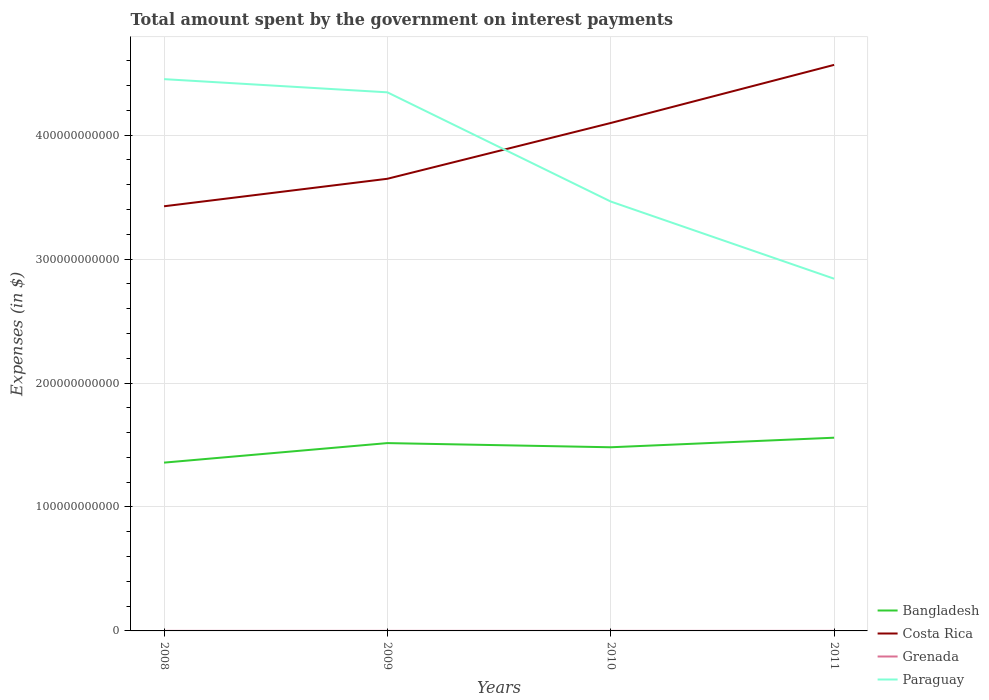Does the line corresponding to Paraguay intersect with the line corresponding to Costa Rica?
Offer a terse response. Yes. Across all years, what is the maximum amount spent on interest payments by the government in Bangladesh?
Provide a short and direct response. 1.36e+11. What is the total amount spent on interest payments by the government in Costa Rica in the graph?
Provide a short and direct response. -9.19e+1. What is the difference between the highest and the second highest amount spent on interest payments by the government in Costa Rica?
Your answer should be compact. 1.14e+11. What is the difference between the highest and the lowest amount spent on interest payments by the government in Paraguay?
Make the answer very short. 2. Is the amount spent on interest payments by the government in Costa Rica strictly greater than the amount spent on interest payments by the government in Grenada over the years?
Provide a succinct answer. No. How many years are there in the graph?
Offer a terse response. 4. What is the difference between two consecutive major ticks on the Y-axis?
Keep it short and to the point. 1.00e+11. Are the values on the major ticks of Y-axis written in scientific E-notation?
Your response must be concise. No. Does the graph contain grids?
Make the answer very short. Yes. Where does the legend appear in the graph?
Make the answer very short. Bottom right. How many legend labels are there?
Make the answer very short. 4. What is the title of the graph?
Your answer should be very brief. Total amount spent by the government on interest payments. Does "Niger" appear as one of the legend labels in the graph?
Offer a terse response. No. What is the label or title of the Y-axis?
Ensure brevity in your answer.  Expenses (in $). What is the Expenses (in $) in Bangladesh in 2008?
Make the answer very short. 1.36e+11. What is the Expenses (in $) of Costa Rica in 2008?
Offer a terse response. 3.43e+11. What is the Expenses (in $) in Grenada in 2008?
Make the answer very short. 3.49e+07. What is the Expenses (in $) of Paraguay in 2008?
Your answer should be compact. 4.45e+11. What is the Expenses (in $) in Bangladesh in 2009?
Give a very brief answer. 1.52e+11. What is the Expenses (in $) in Costa Rica in 2009?
Your answer should be compact. 3.65e+11. What is the Expenses (in $) of Grenada in 2009?
Provide a short and direct response. 4.53e+07. What is the Expenses (in $) in Paraguay in 2009?
Your response must be concise. 4.35e+11. What is the Expenses (in $) in Bangladesh in 2010?
Keep it short and to the point. 1.48e+11. What is the Expenses (in $) of Costa Rica in 2010?
Give a very brief answer. 4.10e+11. What is the Expenses (in $) of Grenada in 2010?
Keep it short and to the point. 4.30e+07. What is the Expenses (in $) of Paraguay in 2010?
Your answer should be very brief. 3.46e+11. What is the Expenses (in $) in Bangladesh in 2011?
Provide a short and direct response. 1.56e+11. What is the Expenses (in $) of Costa Rica in 2011?
Your response must be concise. 4.57e+11. What is the Expenses (in $) of Grenada in 2011?
Make the answer very short. 5.16e+07. What is the Expenses (in $) of Paraguay in 2011?
Provide a succinct answer. 2.84e+11. Across all years, what is the maximum Expenses (in $) in Bangladesh?
Provide a short and direct response. 1.56e+11. Across all years, what is the maximum Expenses (in $) in Costa Rica?
Your answer should be very brief. 4.57e+11. Across all years, what is the maximum Expenses (in $) in Grenada?
Offer a very short reply. 5.16e+07. Across all years, what is the maximum Expenses (in $) of Paraguay?
Offer a terse response. 4.45e+11. Across all years, what is the minimum Expenses (in $) of Bangladesh?
Give a very brief answer. 1.36e+11. Across all years, what is the minimum Expenses (in $) in Costa Rica?
Offer a very short reply. 3.43e+11. Across all years, what is the minimum Expenses (in $) of Grenada?
Provide a short and direct response. 3.49e+07. Across all years, what is the minimum Expenses (in $) of Paraguay?
Offer a terse response. 2.84e+11. What is the total Expenses (in $) of Bangladesh in the graph?
Your answer should be compact. 5.91e+11. What is the total Expenses (in $) in Costa Rica in the graph?
Provide a short and direct response. 1.57e+12. What is the total Expenses (in $) of Grenada in the graph?
Provide a short and direct response. 1.75e+08. What is the total Expenses (in $) of Paraguay in the graph?
Provide a short and direct response. 1.51e+12. What is the difference between the Expenses (in $) of Bangladesh in 2008 and that in 2009?
Provide a short and direct response. -1.58e+1. What is the difference between the Expenses (in $) in Costa Rica in 2008 and that in 2009?
Keep it short and to the point. -2.22e+1. What is the difference between the Expenses (in $) of Grenada in 2008 and that in 2009?
Offer a very short reply. -1.04e+07. What is the difference between the Expenses (in $) of Paraguay in 2008 and that in 2009?
Give a very brief answer. 1.06e+1. What is the difference between the Expenses (in $) in Bangladesh in 2008 and that in 2010?
Your answer should be very brief. -1.24e+1. What is the difference between the Expenses (in $) of Costa Rica in 2008 and that in 2010?
Make the answer very short. -6.72e+1. What is the difference between the Expenses (in $) of Grenada in 2008 and that in 2010?
Your answer should be compact. -8.10e+06. What is the difference between the Expenses (in $) of Paraguay in 2008 and that in 2010?
Your response must be concise. 9.87e+1. What is the difference between the Expenses (in $) in Bangladesh in 2008 and that in 2011?
Your answer should be very brief. -2.01e+1. What is the difference between the Expenses (in $) of Costa Rica in 2008 and that in 2011?
Offer a very short reply. -1.14e+11. What is the difference between the Expenses (in $) of Grenada in 2008 and that in 2011?
Ensure brevity in your answer.  -1.67e+07. What is the difference between the Expenses (in $) in Paraguay in 2008 and that in 2011?
Give a very brief answer. 1.61e+11. What is the difference between the Expenses (in $) in Bangladesh in 2009 and that in 2010?
Provide a short and direct response. 3.37e+09. What is the difference between the Expenses (in $) of Costa Rica in 2009 and that in 2010?
Provide a succinct answer. -4.50e+1. What is the difference between the Expenses (in $) of Grenada in 2009 and that in 2010?
Provide a succinct answer. 2.30e+06. What is the difference between the Expenses (in $) of Paraguay in 2009 and that in 2010?
Offer a terse response. 8.81e+1. What is the difference between the Expenses (in $) of Bangladesh in 2009 and that in 2011?
Give a very brief answer. -4.35e+09. What is the difference between the Expenses (in $) of Costa Rica in 2009 and that in 2011?
Ensure brevity in your answer.  -9.19e+1. What is the difference between the Expenses (in $) of Grenada in 2009 and that in 2011?
Your answer should be very brief. -6.30e+06. What is the difference between the Expenses (in $) in Paraguay in 2009 and that in 2011?
Keep it short and to the point. 1.50e+11. What is the difference between the Expenses (in $) in Bangladesh in 2010 and that in 2011?
Your answer should be compact. -7.72e+09. What is the difference between the Expenses (in $) of Costa Rica in 2010 and that in 2011?
Your answer should be very brief. -4.69e+1. What is the difference between the Expenses (in $) in Grenada in 2010 and that in 2011?
Offer a very short reply. -8.60e+06. What is the difference between the Expenses (in $) of Paraguay in 2010 and that in 2011?
Ensure brevity in your answer.  6.23e+1. What is the difference between the Expenses (in $) of Bangladesh in 2008 and the Expenses (in $) of Costa Rica in 2009?
Make the answer very short. -2.29e+11. What is the difference between the Expenses (in $) of Bangladesh in 2008 and the Expenses (in $) of Grenada in 2009?
Your answer should be compact. 1.36e+11. What is the difference between the Expenses (in $) in Bangladesh in 2008 and the Expenses (in $) in Paraguay in 2009?
Keep it short and to the point. -2.99e+11. What is the difference between the Expenses (in $) of Costa Rica in 2008 and the Expenses (in $) of Grenada in 2009?
Ensure brevity in your answer.  3.43e+11. What is the difference between the Expenses (in $) in Costa Rica in 2008 and the Expenses (in $) in Paraguay in 2009?
Offer a terse response. -9.19e+1. What is the difference between the Expenses (in $) in Grenada in 2008 and the Expenses (in $) in Paraguay in 2009?
Your answer should be very brief. -4.34e+11. What is the difference between the Expenses (in $) in Bangladesh in 2008 and the Expenses (in $) in Costa Rica in 2010?
Give a very brief answer. -2.74e+11. What is the difference between the Expenses (in $) in Bangladesh in 2008 and the Expenses (in $) in Grenada in 2010?
Ensure brevity in your answer.  1.36e+11. What is the difference between the Expenses (in $) of Bangladesh in 2008 and the Expenses (in $) of Paraguay in 2010?
Your response must be concise. -2.11e+11. What is the difference between the Expenses (in $) in Costa Rica in 2008 and the Expenses (in $) in Grenada in 2010?
Offer a very short reply. 3.43e+11. What is the difference between the Expenses (in $) of Costa Rica in 2008 and the Expenses (in $) of Paraguay in 2010?
Make the answer very short. -3.82e+09. What is the difference between the Expenses (in $) of Grenada in 2008 and the Expenses (in $) of Paraguay in 2010?
Provide a succinct answer. -3.46e+11. What is the difference between the Expenses (in $) in Bangladesh in 2008 and the Expenses (in $) in Costa Rica in 2011?
Provide a short and direct response. -3.21e+11. What is the difference between the Expenses (in $) in Bangladesh in 2008 and the Expenses (in $) in Grenada in 2011?
Provide a short and direct response. 1.36e+11. What is the difference between the Expenses (in $) in Bangladesh in 2008 and the Expenses (in $) in Paraguay in 2011?
Keep it short and to the point. -1.48e+11. What is the difference between the Expenses (in $) of Costa Rica in 2008 and the Expenses (in $) of Grenada in 2011?
Give a very brief answer. 3.43e+11. What is the difference between the Expenses (in $) of Costa Rica in 2008 and the Expenses (in $) of Paraguay in 2011?
Keep it short and to the point. 5.84e+1. What is the difference between the Expenses (in $) of Grenada in 2008 and the Expenses (in $) of Paraguay in 2011?
Your response must be concise. -2.84e+11. What is the difference between the Expenses (in $) in Bangladesh in 2009 and the Expenses (in $) in Costa Rica in 2010?
Provide a succinct answer. -2.58e+11. What is the difference between the Expenses (in $) of Bangladesh in 2009 and the Expenses (in $) of Grenada in 2010?
Keep it short and to the point. 1.51e+11. What is the difference between the Expenses (in $) of Bangladesh in 2009 and the Expenses (in $) of Paraguay in 2010?
Provide a short and direct response. -1.95e+11. What is the difference between the Expenses (in $) in Costa Rica in 2009 and the Expenses (in $) in Grenada in 2010?
Give a very brief answer. 3.65e+11. What is the difference between the Expenses (in $) of Costa Rica in 2009 and the Expenses (in $) of Paraguay in 2010?
Offer a very short reply. 1.84e+1. What is the difference between the Expenses (in $) of Grenada in 2009 and the Expenses (in $) of Paraguay in 2010?
Your answer should be compact. -3.46e+11. What is the difference between the Expenses (in $) in Bangladesh in 2009 and the Expenses (in $) in Costa Rica in 2011?
Provide a succinct answer. -3.05e+11. What is the difference between the Expenses (in $) in Bangladesh in 2009 and the Expenses (in $) in Grenada in 2011?
Make the answer very short. 1.51e+11. What is the difference between the Expenses (in $) in Bangladesh in 2009 and the Expenses (in $) in Paraguay in 2011?
Your answer should be compact. -1.33e+11. What is the difference between the Expenses (in $) of Costa Rica in 2009 and the Expenses (in $) of Grenada in 2011?
Provide a short and direct response. 3.65e+11. What is the difference between the Expenses (in $) in Costa Rica in 2009 and the Expenses (in $) in Paraguay in 2011?
Offer a very short reply. 8.06e+1. What is the difference between the Expenses (in $) of Grenada in 2009 and the Expenses (in $) of Paraguay in 2011?
Your response must be concise. -2.84e+11. What is the difference between the Expenses (in $) of Bangladesh in 2010 and the Expenses (in $) of Costa Rica in 2011?
Give a very brief answer. -3.08e+11. What is the difference between the Expenses (in $) of Bangladesh in 2010 and the Expenses (in $) of Grenada in 2011?
Your answer should be very brief. 1.48e+11. What is the difference between the Expenses (in $) in Bangladesh in 2010 and the Expenses (in $) in Paraguay in 2011?
Your answer should be compact. -1.36e+11. What is the difference between the Expenses (in $) in Costa Rica in 2010 and the Expenses (in $) in Grenada in 2011?
Make the answer very short. 4.10e+11. What is the difference between the Expenses (in $) in Costa Rica in 2010 and the Expenses (in $) in Paraguay in 2011?
Your response must be concise. 1.26e+11. What is the difference between the Expenses (in $) of Grenada in 2010 and the Expenses (in $) of Paraguay in 2011?
Make the answer very short. -2.84e+11. What is the average Expenses (in $) of Bangladesh per year?
Provide a succinct answer. 1.48e+11. What is the average Expenses (in $) of Costa Rica per year?
Keep it short and to the point. 3.93e+11. What is the average Expenses (in $) in Grenada per year?
Make the answer very short. 4.37e+07. What is the average Expenses (in $) in Paraguay per year?
Make the answer very short. 3.78e+11. In the year 2008, what is the difference between the Expenses (in $) of Bangladesh and Expenses (in $) of Costa Rica?
Keep it short and to the point. -2.07e+11. In the year 2008, what is the difference between the Expenses (in $) of Bangladesh and Expenses (in $) of Grenada?
Your answer should be very brief. 1.36e+11. In the year 2008, what is the difference between the Expenses (in $) in Bangladesh and Expenses (in $) in Paraguay?
Provide a succinct answer. -3.09e+11. In the year 2008, what is the difference between the Expenses (in $) of Costa Rica and Expenses (in $) of Grenada?
Your answer should be very brief. 3.43e+11. In the year 2008, what is the difference between the Expenses (in $) in Costa Rica and Expenses (in $) in Paraguay?
Provide a succinct answer. -1.03e+11. In the year 2008, what is the difference between the Expenses (in $) of Grenada and Expenses (in $) of Paraguay?
Your answer should be very brief. -4.45e+11. In the year 2009, what is the difference between the Expenses (in $) of Bangladesh and Expenses (in $) of Costa Rica?
Give a very brief answer. -2.13e+11. In the year 2009, what is the difference between the Expenses (in $) in Bangladesh and Expenses (in $) in Grenada?
Ensure brevity in your answer.  1.51e+11. In the year 2009, what is the difference between the Expenses (in $) of Bangladesh and Expenses (in $) of Paraguay?
Your answer should be very brief. -2.83e+11. In the year 2009, what is the difference between the Expenses (in $) of Costa Rica and Expenses (in $) of Grenada?
Your answer should be very brief. 3.65e+11. In the year 2009, what is the difference between the Expenses (in $) in Costa Rica and Expenses (in $) in Paraguay?
Provide a short and direct response. -6.97e+1. In the year 2009, what is the difference between the Expenses (in $) in Grenada and Expenses (in $) in Paraguay?
Provide a short and direct response. -4.34e+11. In the year 2010, what is the difference between the Expenses (in $) of Bangladesh and Expenses (in $) of Costa Rica?
Your response must be concise. -2.62e+11. In the year 2010, what is the difference between the Expenses (in $) of Bangladesh and Expenses (in $) of Grenada?
Your response must be concise. 1.48e+11. In the year 2010, what is the difference between the Expenses (in $) of Bangladesh and Expenses (in $) of Paraguay?
Your answer should be very brief. -1.98e+11. In the year 2010, what is the difference between the Expenses (in $) in Costa Rica and Expenses (in $) in Grenada?
Make the answer very short. 4.10e+11. In the year 2010, what is the difference between the Expenses (in $) in Costa Rica and Expenses (in $) in Paraguay?
Give a very brief answer. 6.34e+1. In the year 2010, what is the difference between the Expenses (in $) of Grenada and Expenses (in $) of Paraguay?
Your answer should be compact. -3.46e+11. In the year 2011, what is the difference between the Expenses (in $) of Bangladesh and Expenses (in $) of Costa Rica?
Your answer should be very brief. -3.01e+11. In the year 2011, what is the difference between the Expenses (in $) in Bangladesh and Expenses (in $) in Grenada?
Provide a short and direct response. 1.56e+11. In the year 2011, what is the difference between the Expenses (in $) of Bangladesh and Expenses (in $) of Paraguay?
Your answer should be compact. -1.28e+11. In the year 2011, what is the difference between the Expenses (in $) of Costa Rica and Expenses (in $) of Grenada?
Provide a short and direct response. 4.57e+11. In the year 2011, what is the difference between the Expenses (in $) of Costa Rica and Expenses (in $) of Paraguay?
Your answer should be very brief. 1.73e+11. In the year 2011, what is the difference between the Expenses (in $) of Grenada and Expenses (in $) of Paraguay?
Provide a short and direct response. -2.84e+11. What is the ratio of the Expenses (in $) of Bangladesh in 2008 to that in 2009?
Provide a succinct answer. 0.9. What is the ratio of the Expenses (in $) in Costa Rica in 2008 to that in 2009?
Keep it short and to the point. 0.94. What is the ratio of the Expenses (in $) of Grenada in 2008 to that in 2009?
Your answer should be compact. 0.77. What is the ratio of the Expenses (in $) in Paraguay in 2008 to that in 2009?
Provide a succinct answer. 1.02. What is the ratio of the Expenses (in $) in Bangladesh in 2008 to that in 2010?
Offer a very short reply. 0.92. What is the ratio of the Expenses (in $) in Costa Rica in 2008 to that in 2010?
Your answer should be compact. 0.84. What is the ratio of the Expenses (in $) of Grenada in 2008 to that in 2010?
Give a very brief answer. 0.81. What is the ratio of the Expenses (in $) of Paraguay in 2008 to that in 2010?
Keep it short and to the point. 1.29. What is the ratio of the Expenses (in $) in Bangladesh in 2008 to that in 2011?
Keep it short and to the point. 0.87. What is the ratio of the Expenses (in $) of Costa Rica in 2008 to that in 2011?
Give a very brief answer. 0.75. What is the ratio of the Expenses (in $) in Grenada in 2008 to that in 2011?
Offer a terse response. 0.68. What is the ratio of the Expenses (in $) of Paraguay in 2008 to that in 2011?
Make the answer very short. 1.57. What is the ratio of the Expenses (in $) of Bangladesh in 2009 to that in 2010?
Ensure brevity in your answer.  1.02. What is the ratio of the Expenses (in $) in Costa Rica in 2009 to that in 2010?
Make the answer very short. 0.89. What is the ratio of the Expenses (in $) of Grenada in 2009 to that in 2010?
Your answer should be compact. 1.05. What is the ratio of the Expenses (in $) in Paraguay in 2009 to that in 2010?
Your response must be concise. 1.25. What is the ratio of the Expenses (in $) of Bangladesh in 2009 to that in 2011?
Make the answer very short. 0.97. What is the ratio of the Expenses (in $) in Costa Rica in 2009 to that in 2011?
Ensure brevity in your answer.  0.8. What is the ratio of the Expenses (in $) of Grenada in 2009 to that in 2011?
Provide a succinct answer. 0.88. What is the ratio of the Expenses (in $) of Paraguay in 2009 to that in 2011?
Offer a terse response. 1.53. What is the ratio of the Expenses (in $) of Bangladesh in 2010 to that in 2011?
Offer a very short reply. 0.95. What is the ratio of the Expenses (in $) in Costa Rica in 2010 to that in 2011?
Give a very brief answer. 0.9. What is the ratio of the Expenses (in $) of Paraguay in 2010 to that in 2011?
Give a very brief answer. 1.22. What is the difference between the highest and the second highest Expenses (in $) of Bangladesh?
Make the answer very short. 4.35e+09. What is the difference between the highest and the second highest Expenses (in $) in Costa Rica?
Your answer should be very brief. 4.69e+1. What is the difference between the highest and the second highest Expenses (in $) of Grenada?
Make the answer very short. 6.30e+06. What is the difference between the highest and the second highest Expenses (in $) in Paraguay?
Your response must be concise. 1.06e+1. What is the difference between the highest and the lowest Expenses (in $) in Bangladesh?
Offer a very short reply. 2.01e+1. What is the difference between the highest and the lowest Expenses (in $) of Costa Rica?
Make the answer very short. 1.14e+11. What is the difference between the highest and the lowest Expenses (in $) in Grenada?
Offer a terse response. 1.67e+07. What is the difference between the highest and the lowest Expenses (in $) of Paraguay?
Provide a short and direct response. 1.61e+11. 